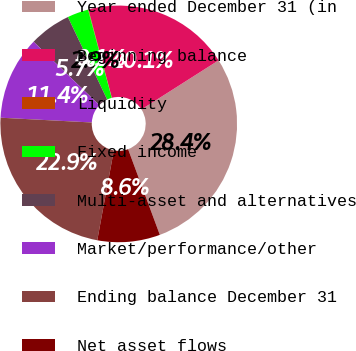Convert chart to OTSL. <chart><loc_0><loc_0><loc_500><loc_500><pie_chart><fcel>Year ended December 31 (in<fcel>Beginning balance<fcel>Liquidity<fcel>Fixed income<fcel>Multi-asset and alternatives<fcel>Market/performance/other<fcel>Ending balance December 31<fcel>Net asset flows<nl><fcel>28.37%<fcel>20.1%<fcel>0.06%<fcel>2.89%<fcel>5.72%<fcel>11.38%<fcel>22.93%<fcel>8.55%<nl></chart> 